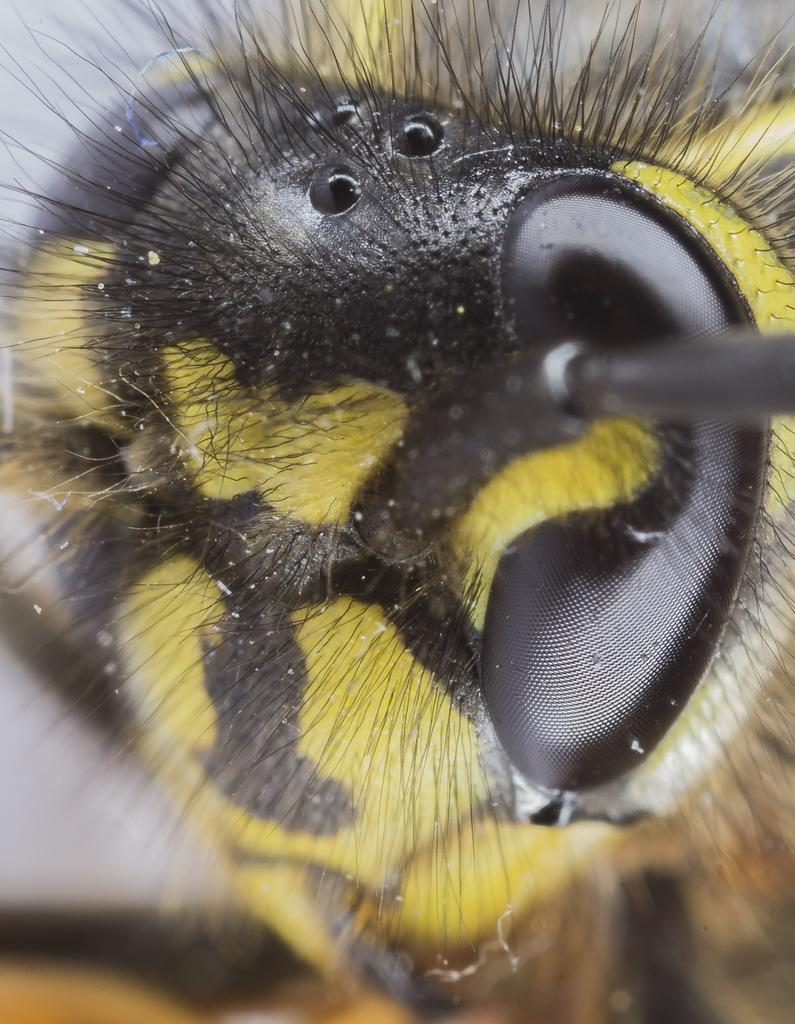What type of creature is present in the image? There is an insect in the image. What feature can be seen on the insect's body? The insect has an eye. What other characteristic is visible on the insect? The insect has hair. What colors can be observed on the insect's body? There are parts of the insect that are yellow in color and parts that are black in color. Where can the boats be seen in the image? There are no boats present in the image; it features an insect with specific features and colors. 